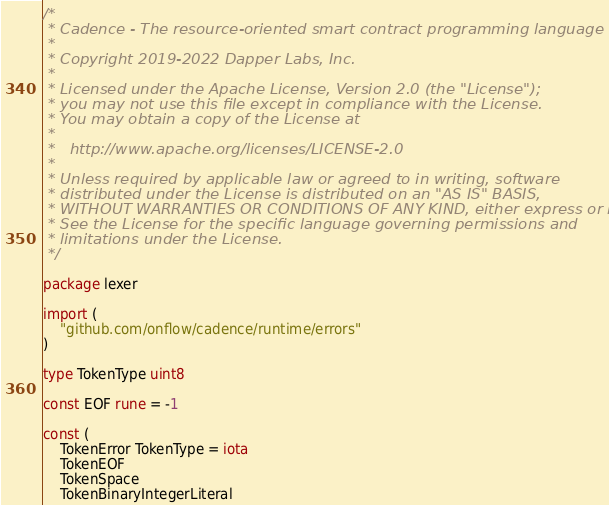<code> <loc_0><loc_0><loc_500><loc_500><_Go_>/*
 * Cadence - The resource-oriented smart contract programming language
 *
 * Copyright 2019-2022 Dapper Labs, Inc.
 *
 * Licensed under the Apache License, Version 2.0 (the "License");
 * you may not use this file except in compliance with the License.
 * You may obtain a copy of the License at
 *
 *   http://www.apache.org/licenses/LICENSE-2.0
 *
 * Unless required by applicable law or agreed to in writing, software
 * distributed under the License is distributed on an "AS IS" BASIS,
 * WITHOUT WARRANTIES OR CONDITIONS OF ANY KIND, either express or implied.
 * See the License for the specific language governing permissions and
 * limitations under the License.
 */

package lexer

import (
	"github.com/onflow/cadence/runtime/errors"
)

type TokenType uint8

const EOF rune = -1

const (
	TokenError TokenType = iota
	TokenEOF
	TokenSpace
	TokenBinaryIntegerLiteral</code> 